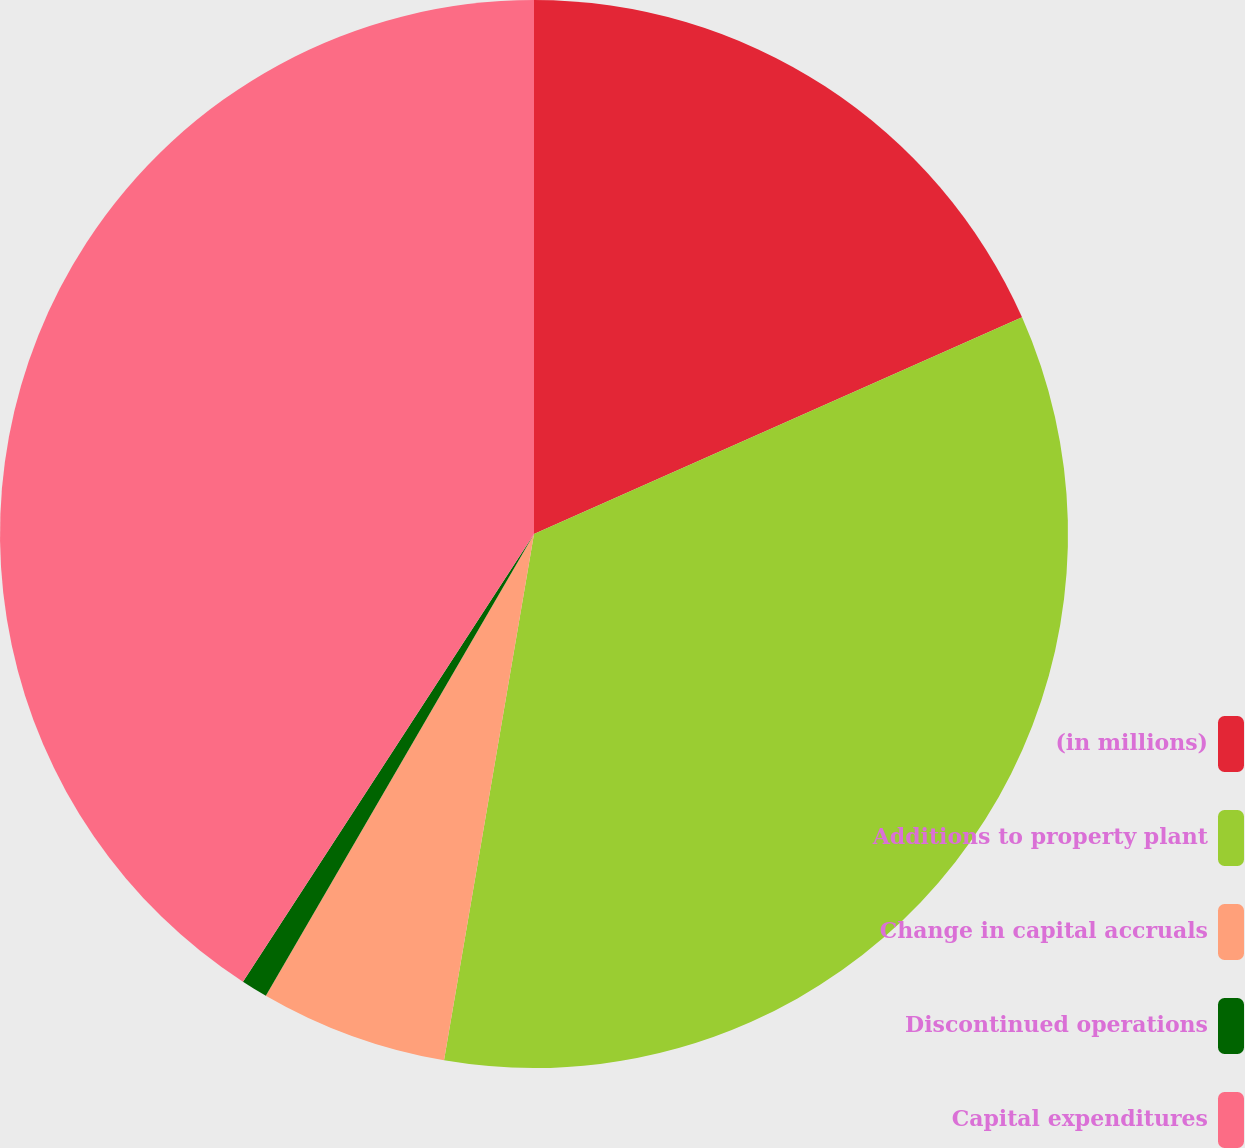Convert chart. <chart><loc_0><loc_0><loc_500><loc_500><pie_chart><fcel>(in millions)<fcel>Additions to property plant<fcel>Change in capital accruals<fcel>Discontinued operations<fcel>Capital expenditures<nl><fcel>18.35%<fcel>34.35%<fcel>5.68%<fcel>0.8%<fcel>40.83%<nl></chart> 